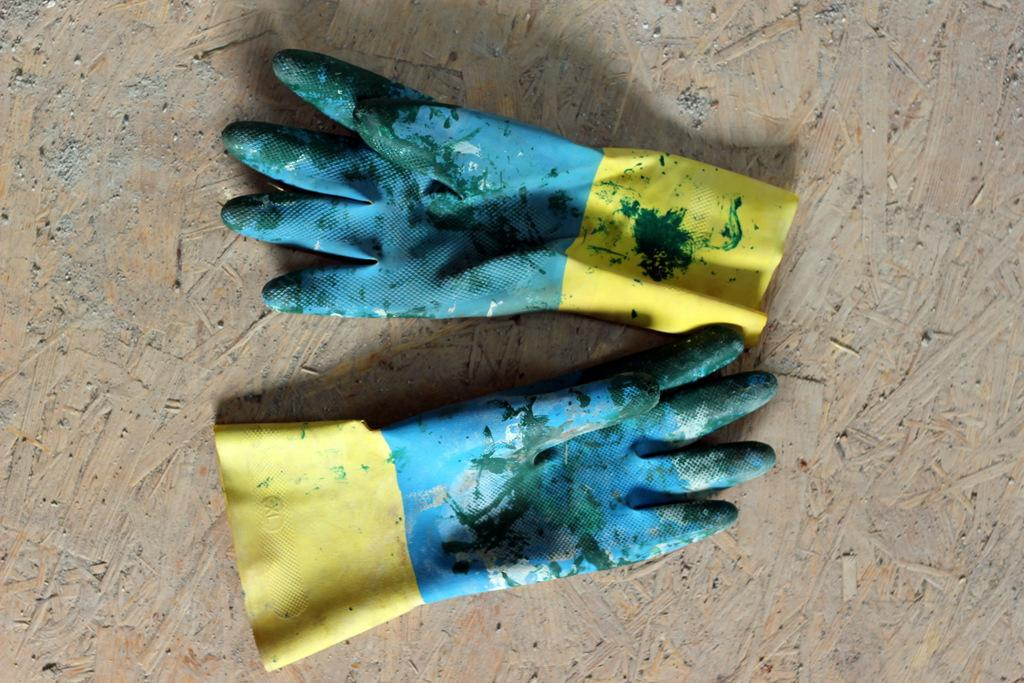What objects are present on the floor in the image? There are two gloves in the image. How are the gloves positioned on the floor? The gloves are kept on the floor. What type of potato is being used to hold the gloves in the image? There is no potato present in the image; the gloves are simply placed on the floor. 